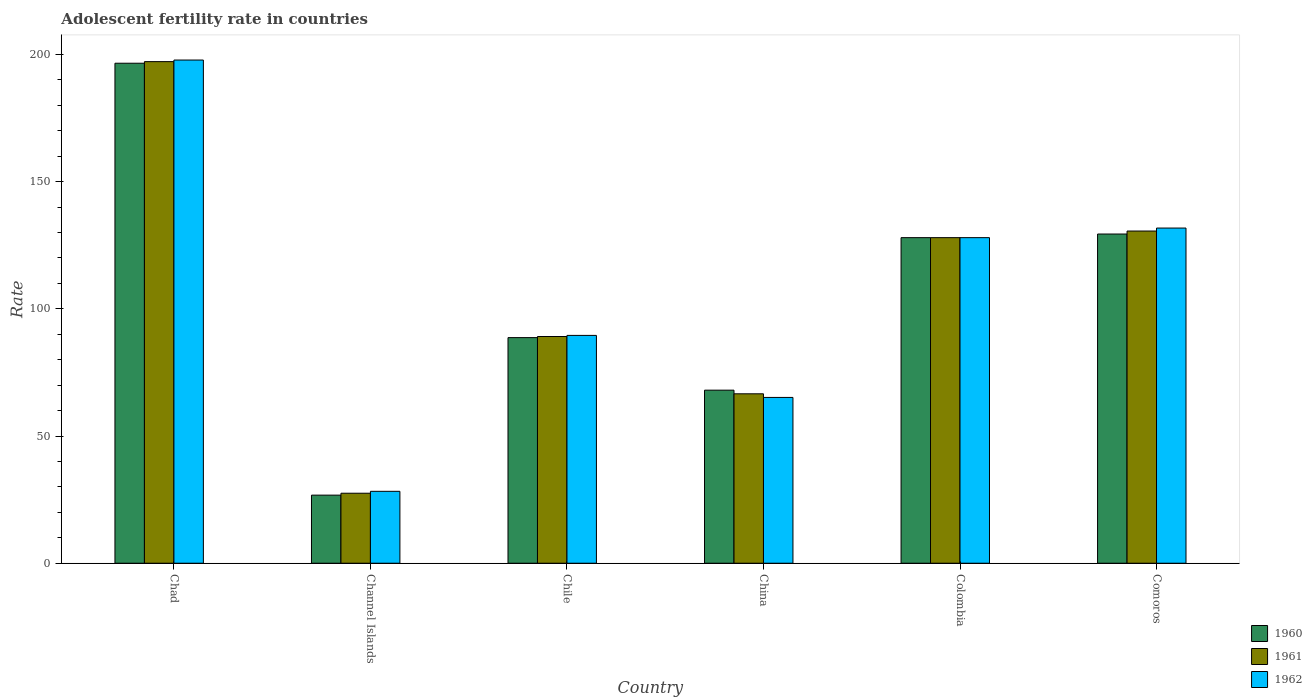How many different coloured bars are there?
Keep it short and to the point. 3. Are the number of bars per tick equal to the number of legend labels?
Offer a very short reply. Yes. Are the number of bars on each tick of the X-axis equal?
Make the answer very short. Yes. What is the label of the 1st group of bars from the left?
Provide a succinct answer. Chad. What is the adolescent fertility rate in 1961 in China?
Your answer should be very brief. 66.61. Across all countries, what is the maximum adolescent fertility rate in 1962?
Ensure brevity in your answer.  197.82. Across all countries, what is the minimum adolescent fertility rate in 1962?
Offer a very short reply. 28.27. In which country was the adolescent fertility rate in 1961 maximum?
Provide a short and direct response. Chad. In which country was the adolescent fertility rate in 1960 minimum?
Ensure brevity in your answer.  Channel Islands. What is the total adolescent fertility rate in 1960 in the graph?
Ensure brevity in your answer.  637.47. What is the difference between the adolescent fertility rate in 1962 in Chad and that in Channel Islands?
Offer a terse response. 169.55. What is the difference between the adolescent fertility rate in 1961 in Chad and the adolescent fertility rate in 1962 in Colombia?
Ensure brevity in your answer.  69.2. What is the average adolescent fertility rate in 1961 per country?
Offer a very short reply. 106.51. What is the difference between the adolescent fertility rate of/in 1962 and adolescent fertility rate of/in 1960 in Chad?
Your answer should be compact. 1.26. In how many countries, is the adolescent fertility rate in 1962 greater than 70?
Ensure brevity in your answer.  4. What is the ratio of the adolescent fertility rate in 1961 in Chad to that in Colombia?
Your response must be concise. 1.54. Is the adolescent fertility rate in 1960 in Colombia less than that in Comoros?
Offer a terse response. Yes. What is the difference between the highest and the second highest adolescent fertility rate in 1961?
Make the answer very short. -66.6. What is the difference between the highest and the lowest adolescent fertility rate in 1962?
Provide a short and direct response. 169.55. What does the 1st bar from the left in Chad represents?
Offer a very short reply. 1960. What does the 3rd bar from the right in Chad represents?
Offer a terse response. 1960. Is it the case that in every country, the sum of the adolescent fertility rate in 1961 and adolescent fertility rate in 1960 is greater than the adolescent fertility rate in 1962?
Your response must be concise. Yes. How many bars are there?
Make the answer very short. 18. Are all the bars in the graph horizontal?
Provide a short and direct response. No. Where does the legend appear in the graph?
Make the answer very short. Bottom right. How many legend labels are there?
Your response must be concise. 3. How are the legend labels stacked?
Your answer should be very brief. Vertical. What is the title of the graph?
Your answer should be very brief. Adolescent fertility rate in countries. Does "1984" appear as one of the legend labels in the graph?
Your answer should be compact. No. What is the label or title of the Y-axis?
Keep it short and to the point. Rate. What is the Rate of 1960 in Chad?
Give a very brief answer. 196.56. What is the Rate of 1961 in Chad?
Offer a terse response. 197.19. What is the Rate in 1962 in Chad?
Give a very brief answer. 197.82. What is the Rate in 1960 in Channel Islands?
Keep it short and to the point. 26.77. What is the Rate of 1961 in Channel Islands?
Give a very brief answer. 27.52. What is the Rate in 1962 in Channel Islands?
Provide a short and direct response. 28.27. What is the Rate of 1960 in Chile?
Offer a very short reply. 88.69. What is the Rate of 1961 in Chile?
Ensure brevity in your answer.  89.13. What is the Rate of 1962 in Chile?
Give a very brief answer. 89.57. What is the Rate of 1960 in China?
Give a very brief answer. 68.03. What is the Rate of 1961 in China?
Your response must be concise. 66.61. What is the Rate of 1962 in China?
Your answer should be very brief. 65.18. What is the Rate of 1960 in Colombia?
Offer a terse response. 127.99. What is the Rate of 1961 in Colombia?
Ensure brevity in your answer.  127.99. What is the Rate in 1962 in Colombia?
Make the answer very short. 127.99. What is the Rate of 1960 in Comoros?
Your answer should be very brief. 129.42. What is the Rate of 1961 in Comoros?
Your answer should be very brief. 130.59. What is the Rate of 1962 in Comoros?
Your answer should be very brief. 131.77. Across all countries, what is the maximum Rate of 1960?
Offer a terse response. 196.56. Across all countries, what is the maximum Rate in 1961?
Your answer should be very brief. 197.19. Across all countries, what is the maximum Rate in 1962?
Provide a short and direct response. 197.82. Across all countries, what is the minimum Rate in 1960?
Make the answer very short. 26.77. Across all countries, what is the minimum Rate in 1961?
Keep it short and to the point. 27.52. Across all countries, what is the minimum Rate in 1962?
Ensure brevity in your answer.  28.27. What is the total Rate of 1960 in the graph?
Your answer should be compact. 637.47. What is the total Rate of 1961 in the graph?
Ensure brevity in your answer.  639.03. What is the total Rate in 1962 in the graph?
Provide a succinct answer. 640.6. What is the difference between the Rate in 1960 in Chad and that in Channel Islands?
Ensure brevity in your answer.  169.8. What is the difference between the Rate in 1961 in Chad and that in Channel Islands?
Provide a short and direct response. 169.67. What is the difference between the Rate in 1962 in Chad and that in Channel Islands?
Your answer should be very brief. 169.55. What is the difference between the Rate in 1960 in Chad and that in Chile?
Offer a very short reply. 107.87. What is the difference between the Rate in 1961 in Chad and that in Chile?
Offer a very short reply. 108.06. What is the difference between the Rate in 1962 in Chad and that in Chile?
Ensure brevity in your answer.  108.25. What is the difference between the Rate in 1960 in Chad and that in China?
Your answer should be very brief. 128.53. What is the difference between the Rate in 1961 in Chad and that in China?
Offer a terse response. 130.59. What is the difference between the Rate in 1962 in Chad and that in China?
Provide a short and direct response. 132.64. What is the difference between the Rate of 1960 in Chad and that in Colombia?
Make the answer very short. 68.57. What is the difference between the Rate of 1961 in Chad and that in Colombia?
Your answer should be compact. 69.2. What is the difference between the Rate in 1962 in Chad and that in Colombia?
Your answer should be very brief. 69.83. What is the difference between the Rate of 1960 in Chad and that in Comoros?
Your answer should be very brief. 67.15. What is the difference between the Rate in 1961 in Chad and that in Comoros?
Your answer should be compact. 66.6. What is the difference between the Rate in 1962 in Chad and that in Comoros?
Make the answer very short. 66.05. What is the difference between the Rate in 1960 in Channel Islands and that in Chile?
Keep it short and to the point. -61.92. What is the difference between the Rate in 1961 in Channel Islands and that in Chile?
Your response must be concise. -61.61. What is the difference between the Rate of 1962 in Channel Islands and that in Chile?
Ensure brevity in your answer.  -61.3. What is the difference between the Rate in 1960 in Channel Islands and that in China?
Your answer should be compact. -41.26. What is the difference between the Rate of 1961 in Channel Islands and that in China?
Ensure brevity in your answer.  -39.09. What is the difference between the Rate in 1962 in Channel Islands and that in China?
Ensure brevity in your answer.  -36.91. What is the difference between the Rate in 1960 in Channel Islands and that in Colombia?
Your answer should be very brief. -101.23. What is the difference between the Rate of 1961 in Channel Islands and that in Colombia?
Give a very brief answer. -100.48. What is the difference between the Rate in 1962 in Channel Islands and that in Colombia?
Provide a succinct answer. -99.72. What is the difference between the Rate in 1960 in Channel Islands and that in Comoros?
Your response must be concise. -102.65. What is the difference between the Rate of 1961 in Channel Islands and that in Comoros?
Offer a very short reply. -103.07. What is the difference between the Rate of 1962 in Channel Islands and that in Comoros?
Offer a very short reply. -103.5. What is the difference between the Rate of 1960 in Chile and that in China?
Offer a terse response. 20.66. What is the difference between the Rate of 1961 in Chile and that in China?
Your answer should be very brief. 22.52. What is the difference between the Rate in 1962 in Chile and that in China?
Your answer should be very brief. 24.39. What is the difference between the Rate of 1960 in Chile and that in Colombia?
Give a very brief answer. -39.3. What is the difference between the Rate in 1961 in Chile and that in Colombia?
Keep it short and to the point. -38.86. What is the difference between the Rate in 1962 in Chile and that in Colombia?
Give a very brief answer. -38.43. What is the difference between the Rate in 1960 in Chile and that in Comoros?
Provide a succinct answer. -40.73. What is the difference between the Rate in 1961 in Chile and that in Comoros?
Your answer should be very brief. -41.46. What is the difference between the Rate of 1962 in Chile and that in Comoros?
Offer a terse response. -42.2. What is the difference between the Rate of 1960 in China and that in Colombia?
Provide a short and direct response. -59.96. What is the difference between the Rate of 1961 in China and that in Colombia?
Make the answer very short. -61.39. What is the difference between the Rate in 1962 in China and that in Colombia?
Offer a terse response. -62.82. What is the difference between the Rate in 1960 in China and that in Comoros?
Make the answer very short. -61.39. What is the difference between the Rate in 1961 in China and that in Comoros?
Ensure brevity in your answer.  -63.99. What is the difference between the Rate in 1962 in China and that in Comoros?
Your response must be concise. -66.59. What is the difference between the Rate of 1960 in Colombia and that in Comoros?
Your answer should be very brief. -1.42. What is the difference between the Rate in 1961 in Colombia and that in Comoros?
Keep it short and to the point. -2.6. What is the difference between the Rate of 1962 in Colombia and that in Comoros?
Offer a terse response. -3.77. What is the difference between the Rate of 1960 in Chad and the Rate of 1961 in Channel Islands?
Provide a succinct answer. 169.05. What is the difference between the Rate in 1960 in Chad and the Rate in 1962 in Channel Islands?
Keep it short and to the point. 168.29. What is the difference between the Rate in 1961 in Chad and the Rate in 1962 in Channel Islands?
Offer a terse response. 168.92. What is the difference between the Rate in 1960 in Chad and the Rate in 1961 in Chile?
Give a very brief answer. 107.43. What is the difference between the Rate in 1960 in Chad and the Rate in 1962 in Chile?
Give a very brief answer. 107. What is the difference between the Rate of 1961 in Chad and the Rate of 1962 in Chile?
Your response must be concise. 107.62. What is the difference between the Rate in 1960 in Chad and the Rate in 1961 in China?
Offer a very short reply. 129.96. What is the difference between the Rate in 1960 in Chad and the Rate in 1962 in China?
Your answer should be compact. 131.39. What is the difference between the Rate of 1961 in Chad and the Rate of 1962 in China?
Keep it short and to the point. 132.01. What is the difference between the Rate of 1960 in Chad and the Rate of 1961 in Colombia?
Make the answer very short. 68.57. What is the difference between the Rate of 1960 in Chad and the Rate of 1962 in Colombia?
Provide a succinct answer. 68.57. What is the difference between the Rate of 1961 in Chad and the Rate of 1962 in Colombia?
Provide a succinct answer. 69.2. What is the difference between the Rate in 1960 in Chad and the Rate in 1961 in Comoros?
Provide a short and direct response. 65.97. What is the difference between the Rate in 1960 in Chad and the Rate in 1962 in Comoros?
Provide a short and direct response. 64.8. What is the difference between the Rate in 1961 in Chad and the Rate in 1962 in Comoros?
Offer a terse response. 65.42. What is the difference between the Rate in 1960 in Channel Islands and the Rate in 1961 in Chile?
Provide a short and direct response. -62.36. What is the difference between the Rate in 1960 in Channel Islands and the Rate in 1962 in Chile?
Offer a very short reply. -62.8. What is the difference between the Rate in 1961 in Channel Islands and the Rate in 1962 in Chile?
Your answer should be very brief. -62.05. What is the difference between the Rate of 1960 in Channel Islands and the Rate of 1961 in China?
Ensure brevity in your answer.  -39.84. What is the difference between the Rate in 1960 in Channel Islands and the Rate in 1962 in China?
Offer a terse response. -38.41. What is the difference between the Rate of 1961 in Channel Islands and the Rate of 1962 in China?
Ensure brevity in your answer.  -37.66. What is the difference between the Rate in 1960 in Channel Islands and the Rate in 1961 in Colombia?
Your answer should be compact. -101.23. What is the difference between the Rate of 1960 in Channel Islands and the Rate of 1962 in Colombia?
Your answer should be very brief. -101.23. What is the difference between the Rate of 1961 in Channel Islands and the Rate of 1962 in Colombia?
Your response must be concise. -100.48. What is the difference between the Rate in 1960 in Channel Islands and the Rate in 1961 in Comoros?
Offer a very short reply. -103.82. What is the difference between the Rate of 1960 in Channel Islands and the Rate of 1962 in Comoros?
Ensure brevity in your answer.  -105. What is the difference between the Rate of 1961 in Channel Islands and the Rate of 1962 in Comoros?
Make the answer very short. -104.25. What is the difference between the Rate in 1960 in Chile and the Rate in 1961 in China?
Your response must be concise. 22.09. What is the difference between the Rate of 1960 in Chile and the Rate of 1962 in China?
Offer a terse response. 23.51. What is the difference between the Rate in 1961 in Chile and the Rate in 1962 in China?
Offer a terse response. 23.95. What is the difference between the Rate of 1960 in Chile and the Rate of 1961 in Colombia?
Offer a very short reply. -39.3. What is the difference between the Rate of 1960 in Chile and the Rate of 1962 in Colombia?
Your answer should be compact. -39.3. What is the difference between the Rate of 1961 in Chile and the Rate of 1962 in Colombia?
Your answer should be compact. -38.86. What is the difference between the Rate of 1960 in Chile and the Rate of 1961 in Comoros?
Your response must be concise. -41.9. What is the difference between the Rate of 1960 in Chile and the Rate of 1962 in Comoros?
Your answer should be very brief. -43.08. What is the difference between the Rate in 1961 in Chile and the Rate in 1962 in Comoros?
Your answer should be compact. -42.64. What is the difference between the Rate in 1960 in China and the Rate in 1961 in Colombia?
Offer a terse response. -59.96. What is the difference between the Rate of 1960 in China and the Rate of 1962 in Colombia?
Provide a short and direct response. -59.96. What is the difference between the Rate of 1961 in China and the Rate of 1962 in Colombia?
Offer a terse response. -61.39. What is the difference between the Rate of 1960 in China and the Rate of 1961 in Comoros?
Offer a very short reply. -62.56. What is the difference between the Rate in 1960 in China and the Rate in 1962 in Comoros?
Keep it short and to the point. -63.73. What is the difference between the Rate of 1961 in China and the Rate of 1962 in Comoros?
Provide a succinct answer. -65.16. What is the difference between the Rate of 1960 in Colombia and the Rate of 1961 in Comoros?
Your answer should be compact. -2.6. What is the difference between the Rate of 1960 in Colombia and the Rate of 1962 in Comoros?
Your answer should be compact. -3.77. What is the difference between the Rate in 1961 in Colombia and the Rate in 1962 in Comoros?
Keep it short and to the point. -3.77. What is the average Rate in 1960 per country?
Your response must be concise. 106.25. What is the average Rate in 1961 per country?
Offer a very short reply. 106.51. What is the average Rate of 1962 per country?
Make the answer very short. 106.77. What is the difference between the Rate of 1960 and Rate of 1961 in Chad?
Your response must be concise. -0.63. What is the difference between the Rate in 1960 and Rate in 1962 in Chad?
Your answer should be very brief. -1.26. What is the difference between the Rate of 1961 and Rate of 1962 in Chad?
Your response must be concise. -0.63. What is the difference between the Rate of 1960 and Rate of 1961 in Channel Islands?
Your response must be concise. -0.75. What is the difference between the Rate in 1960 and Rate in 1962 in Channel Islands?
Your answer should be compact. -1.5. What is the difference between the Rate of 1961 and Rate of 1962 in Channel Islands?
Give a very brief answer. -0.75. What is the difference between the Rate of 1960 and Rate of 1961 in Chile?
Offer a very short reply. -0.44. What is the difference between the Rate of 1960 and Rate of 1962 in Chile?
Offer a terse response. -0.88. What is the difference between the Rate of 1961 and Rate of 1962 in Chile?
Keep it short and to the point. -0.44. What is the difference between the Rate in 1960 and Rate in 1961 in China?
Offer a terse response. 1.43. What is the difference between the Rate in 1960 and Rate in 1962 in China?
Give a very brief answer. 2.86. What is the difference between the Rate of 1961 and Rate of 1962 in China?
Offer a very short reply. 1.43. What is the difference between the Rate of 1960 and Rate of 1961 in Colombia?
Keep it short and to the point. 0. What is the difference between the Rate of 1961 and Rate of 1962 in Colombia?
Your answer should be very brief. 0. What is the difference between the Rate of 1960 and Rate of 1961 in Comoros?
Keep it short and to the point. -1.17. What is the difference between the Rate in 1960 and Rate in 1962 in Comoros?
Offer a terse response. -2.35. What is the difference between the Rate of 1961 and Rate of 1962 in Comoros?
Your answer should be very brief. -1.17. What is the ratio of the Rate of 1960 in Chad to that in Channel Islands?
Offer a terse response. 7.34. What is the ratio of the Rate in 1961 in Chad to that in Channel Islands?
Your response must be concise. 7.17. What is the ratio of the Rate of 1962 in Chad to that in Channel Islands?
Provide a short and direct response. 7. What is the ratio of the Rate in 1960 in Chad to that in Chile?
Offer a very short reply. 2.22. What is the ratio of the Rate of 1961 in Chad to that in Chile?
Provide a short and direct response. 2.21. What is the ratio of the Rate in 1962 in Chad to that in Chile?
Make the answer very short. 2.21. What is the ratio of the Rate of 1960 in Chad to that in China?
Ensure brevity in your answer.  2.89. What is the ratio of the Rate in 1961 in Chad to that in China?
Keep it short and to the point. 2.96. What is the ratio of the Rate of 1962 in Chad to that in China?
Your response must be concise. 3.04. What is the ratio of the Rate in 1960 in Chad to that in Colombia?
Provide a succinct answer. 1.54. What is the ratio of the Rate of 1961 in Chad to that in Colombia?
Provide a short and direct response. 1.54. What is the ratio of the Rate of 1962 in Chad to that in Colombia?
Your answer should be very brief. 1.55. What is the ratio of the Rate in 1960 in Chad to that in Comoros?
Ensure brevity in your answer.  1.52. What is the ratio of the Rate in 1961 in Chad to that in Comoros?
Give a very brief answer. 1.51. What is the ratio of the Rate of 1962 in Chad to that in Comoros?
Your response must be concise. 1.5. What is the ratio of the Rate of 1960 in Channel Islands to that in Chile?
Ensure brevity in your answer.  0.3. What is the ratio of the Rate in 1961 in Channel Islands to that in Chile?
Your answer should be very brief. 0.31. What is the ratio of the Rate of 1962 in Channel Islands to that in Chile?
Make the answer very short. 0.32. What is the ratio of the Rate of 1960 in Channel Islands to that in China?
Your answer should be very brief. 0.39. What is the ratio of the Rate of 1961 in Channel Islands to that in China?
Your answer should be very brief. 0.41. What is the ratio of the Rate of 1962 in Channel Islands to that in China?
Provide a short and direct response. 0.43. What is the ratio of the Rate of 1960 in Channel Islands to that in Colombia?
Give a very brief answer. 0.21. What is the ratio of the Rate in 1961 in Channel Islands to that in Colombia?
Ensure brevity in your answer.  0.21. What is the ratio of the Rate in 1962 in Channel Islands to that in Colombia?
Offer a terse response. 0.22. What is the ratio of the Rate in 1960 in Channel Islands to that in Comoros?
Give a very brief answer. 0.21. What is the ratio of the Rate of 1961 in Channel Islands to that in Comoros?
Your response must be concise. 0.21. What is the ratio of the Rate in 1962 in Channel Islands to that in Comoros?
Make the answer very short. 0.21. What is the ratio of the Rate of 1960 in Chile to that in China?
Provide a short and direct response. 1.3. What is the ratio of the Rate of 1961 in Chile to that in China?
Give a very brief answer. 1.34. What is the ratio of the Rate in 1962 in Chile to that in China?
Provide a succinct answer. 1.37. What is the ratio of the Rate of 1960 in Chile to that in Colombia?
Make the answer very short. 0.69. What is the ratio of the Rate in 1961 in Chile to that in Colombia?
Your answer should be compact. 0.7. What is the ratio of the Rate in 1962 in Chile to that in Colombia?
Provide a succinct answer. 0.7. What is the ratio of the Rate of 1960 in Chile to that in Comoros?
Your response must be concise. 0.69. What is the ratio of the Rate in 1961 in Chile to that in Comoros?
Give a very brief answer. 0.68. What is the ratio of the Rate in 1962 in Chile to that in Comoros?
Your answer should be compact. 0.68. What is the ratio of the Rate in 1960 in China to that in Colombia?
Ensure brevity in your answer.  0.53. What is the ratio of the Rate of 1961 in China to that in Colombia?
Your answer should be very brief. 0.52. What is the ratio of the Rate of 1962 in China to that in Colombia?
Your answer should be compact. 0.51. What is the ratio of the Rate in 1960 in China to that in Comoros?
Provide a short and direct response. 0.53. What is the ratio of the Rate in 1961 in China to that in Comoros?
Give a very brief answer. 0.51. What is the ratio of the Rate of 1962 in China to that in Comoros?
Make the answer very short. 0.49. What is the ratio of the Rate of 1961 in Colombia to that in Comoros?
Give a very brief answer. 0.98. What is the ratio of the Rate in 1962 in Colombia to that in Comoros?
Your answer should be very brief. 0.97. What is the difference between the highest and the second highest Rate in 1960?
Offer a very short reply. 67.15. What is the difference between the highest and the second highest Rate of 1961?
Provide a succinct answer. 66.6. What is the difference between the highest and the second highest Rate of 1962?
Provide a succinct answer. 66.05. What is the difference between the highest and the lowest Rate of 1960?
Your answer should be compact. 169.8. What is the difference between the highest and the lowest Rate of 1961?
Ensure brevity in your answer.  169.67. What is the difference between the highest and the lowest Rate in 1962?
Your response must be concise. 169.55. 